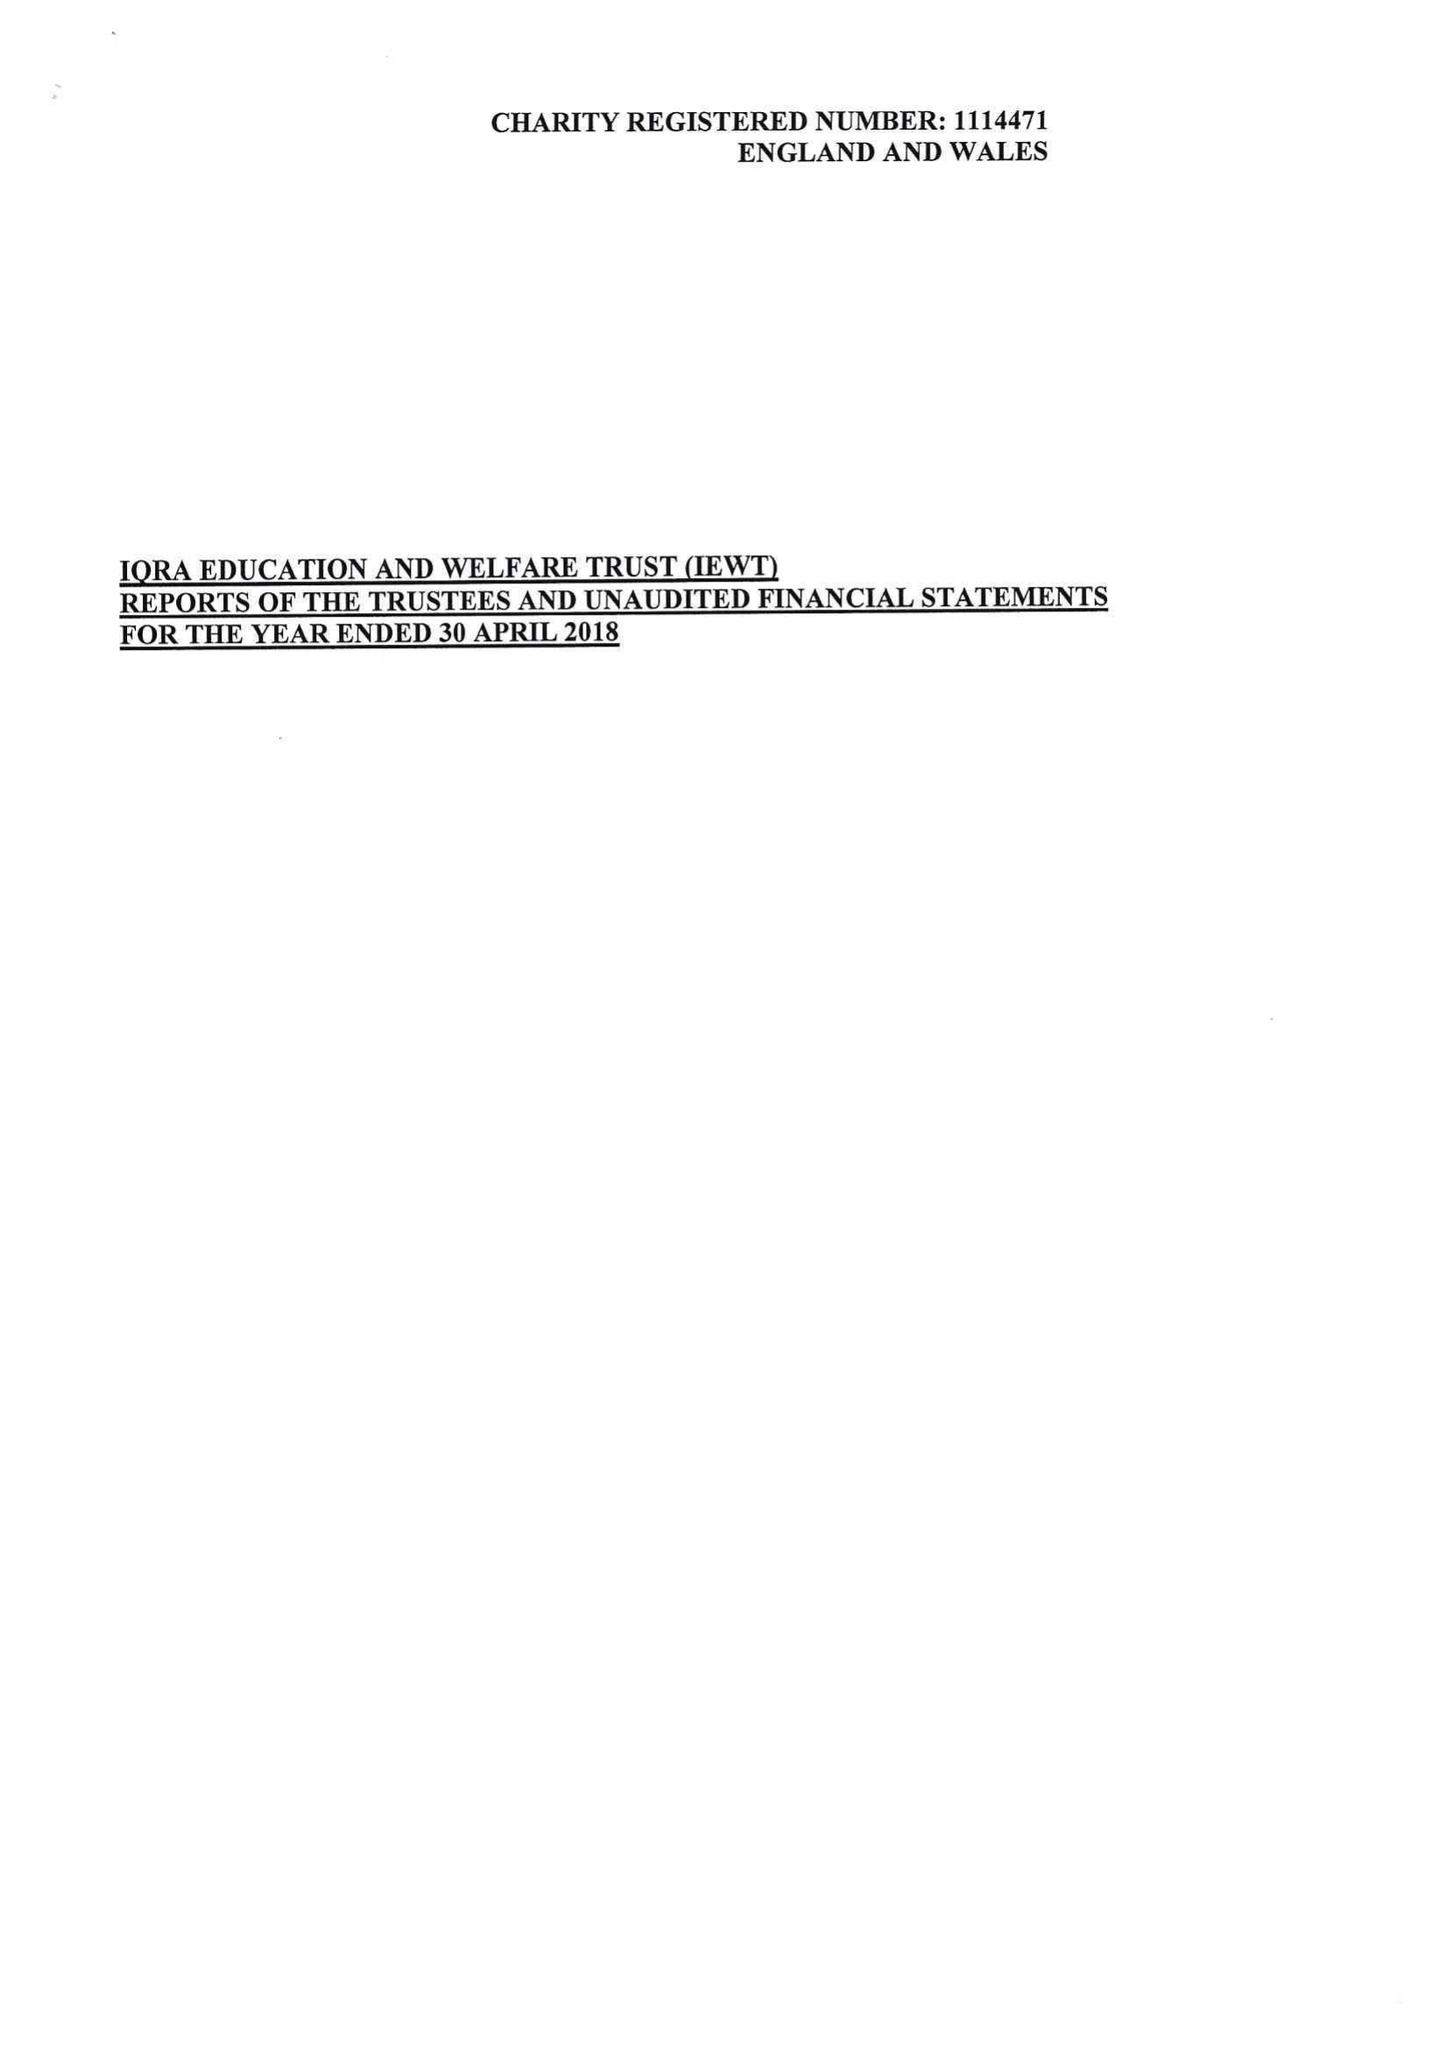What is the value for the charity_name?
Answer the question using a single word or phrase. Iqra Education and Welfare Trust (Iewt) 